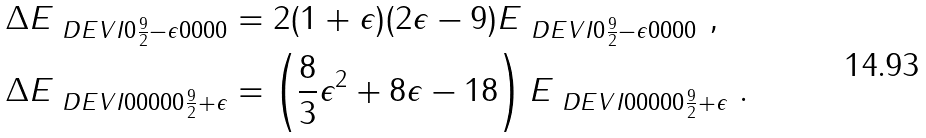<formula> <loc_0><loc_0><loc_500><loc_500>\Delta E _ { \ D E V I { 0 } { \frac { 9 } { 2 } - \epsilon } { 0 } { 0 } { 0 } { 0 } } & = 2 ( 1 + \epsilon ) ( 2 \epsilon - 9 ) E _ { \ D E V I { 0 } { \frac { 9 } { 2 } - \epsilon } { 0 } { 0 } { 0 } { 0 } } \ , \\ \Delta E _ { \ D E V I { 0 } { 0 } { 0 } { 0 } { 0 } { \frac { 9 } { 2 } + \epsilon } } & = \left ( \frac { 8 } 3 \epsilon ^ { 2 } + 8 \epsilon - 1 8 \right ) E _ { \ D E V I { 0 } { 0 } { 0 } { 0 } { 0 } { \frac { 9 } { 2 } + \epsilon } } \ .</formula> 